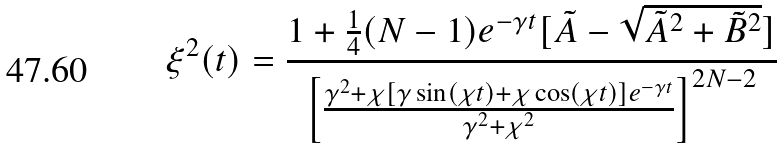Convert formula to latex. <formula><loc_0><loc_0><loc_500><loc_500>\xi ^ { 2 } ( t ) = \frac { 1 + \frac { 1 } { 4 } ( N - 1 ) e ^ { - \gamma t } [ \tilde { A } - \sqrt { \tilde { A } ^ { 2 } + \tilde { B } ^ { 2 } } ] } { \left [ \frac { \gamma ^ { 2 } + \chi [ \gamma \sin ( \chi t ) + \chi \cos ( \chi t ) ] e ^ { - \gamma t } } { \gamma ^ { 2 } + \chi ^ { 2 } } \right ] ^ { 2 N - 2 } }</formula> 